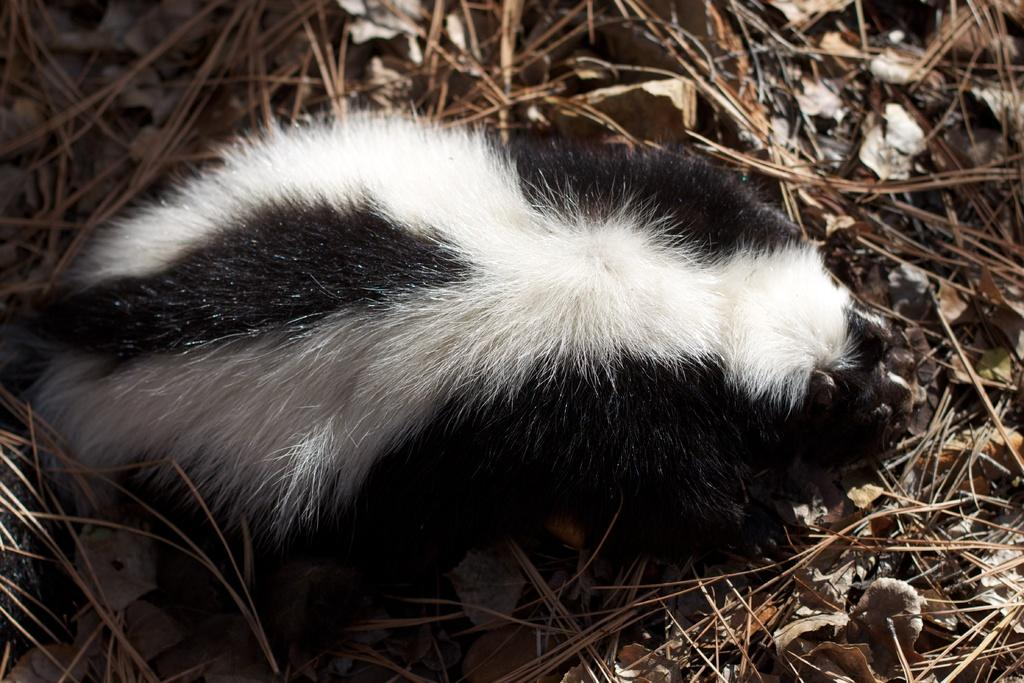What type of animal is in the picture? The type of animal cannot be determined from the provided facts. What can be seen in the background of the picture? There are leaves and dried grass in the background of the picture. What type of cracker is the animal holding in its mouth? There is no cracker or mouth present in the image, as the type of animal cannot be determined from the provided facts. 